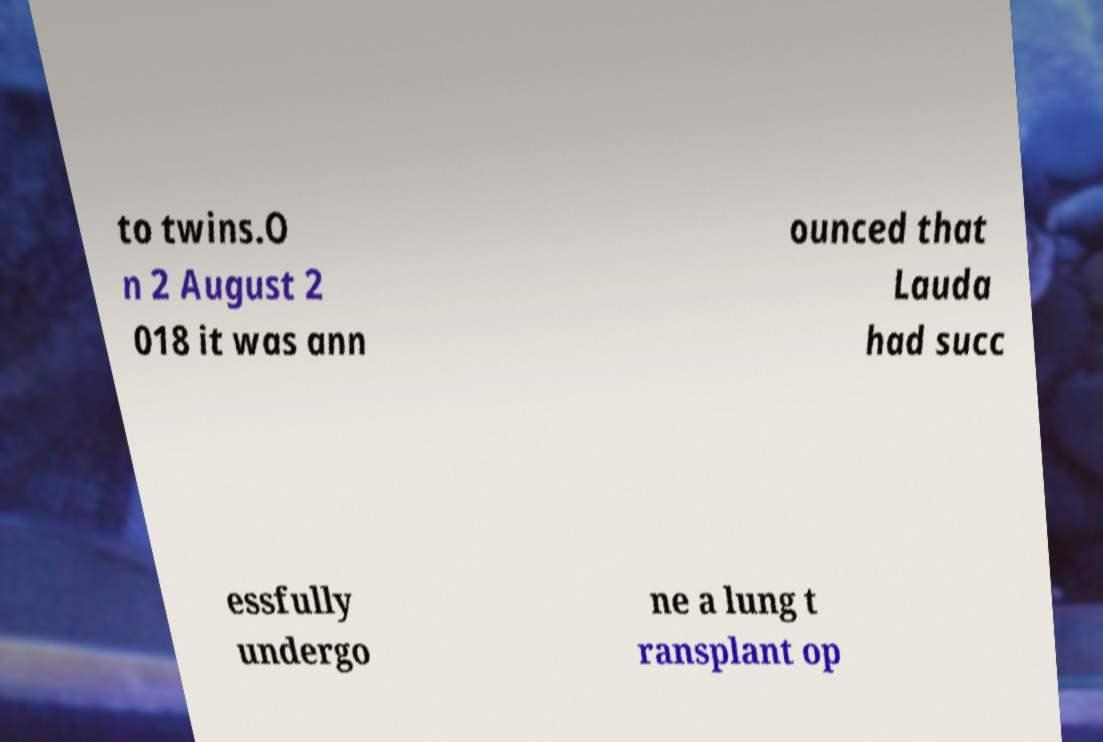What messages or text are displayed in this image? I need them in a readable, typed format. to twins.O n 2 August 2 018 it was ann ounced that Lauda had succ essfully undergo ne a lung t ransplant op 